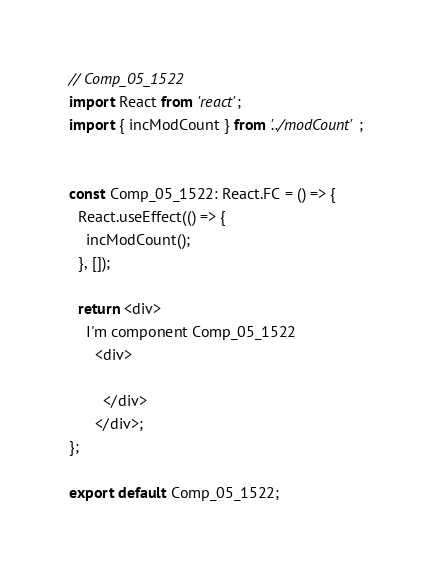<code> <loc_0><loc_0><loc_500><loc_500><_TypeScript_>// Comp_05_1522
import React from 'react';
import { incModCount } from '../modCount';


const Comp_05_1522: React.FC = () => {
  React.useEffect(() => {
    incModCount();
  }, []);

  return <div>
    I'm component Comp_05_1522
      <div>
      
        </div>
      </div>;
};

export default Comp_05_1522;
</code> 